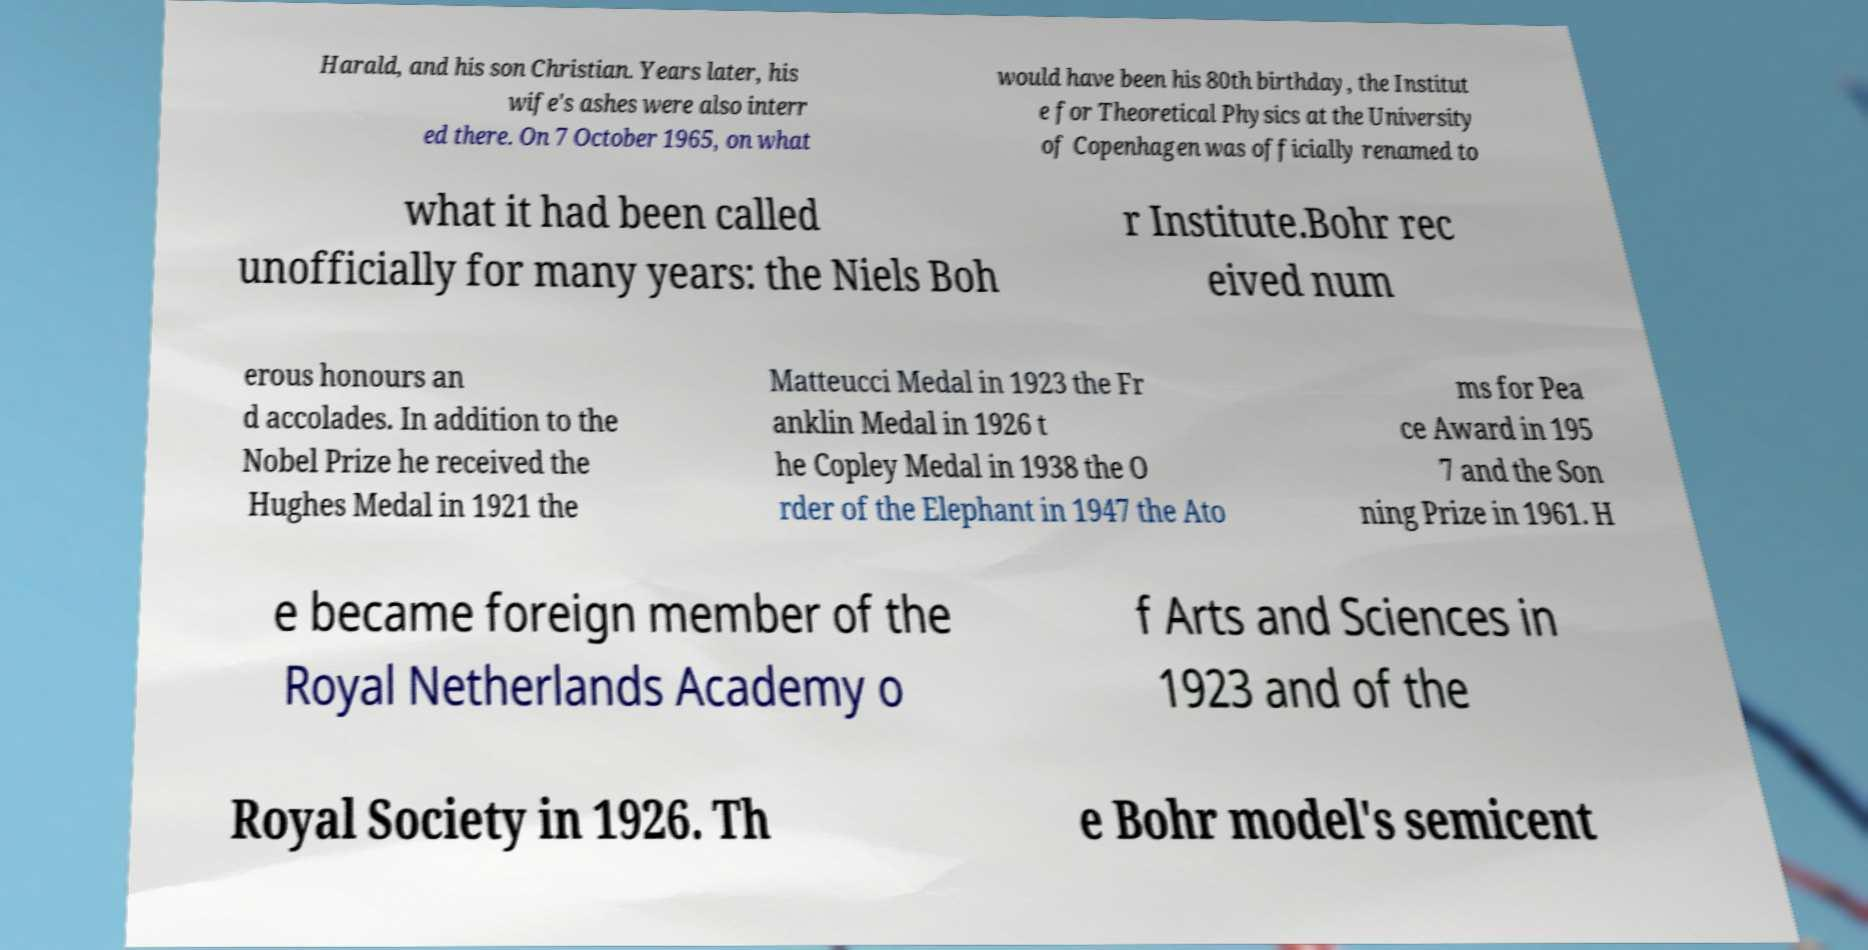Please identify and transcribe the text found in this image. Harald, and his son Christian. Years later, his wife's ashes were also interr ed there. On 7 October 1965, on what would have been his 80th birthday, the Institut e for Theoretical Physics at the University of Copenhagen was officially renamed to what it had been called unofficially for many years: the Niels Boh r Institute.Bohr rec eived num erous honours an d accolades. In addition to the Nobel Prize he received the Hughes Medal in 1921 the Matteucci Medal in 1923 the Fr anklin Medal in 1926 t he Copley Medal in 1938 the O rder of the Elephant in 1947 the Ato ms for Pea ce Award in 195 7 and the Son ning Prize in 1961. H e became foreign member of the Royal Netherlands Academy o f Arts and Sciences in 1923 and of the Royal Society in 1926. Th e Bohr model's semicent 